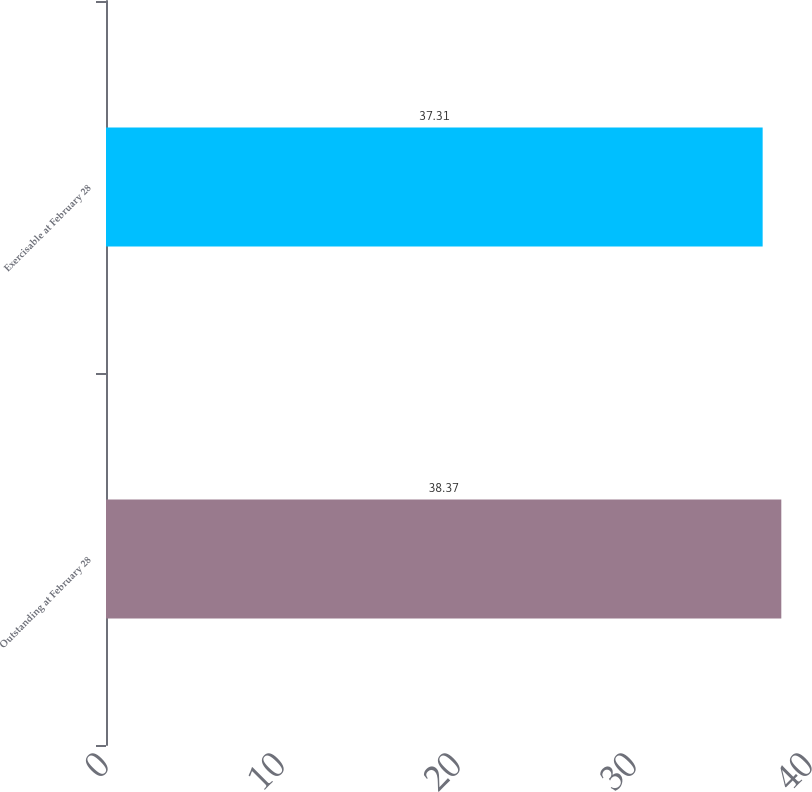<chart> <loc_0><loc_0><loc_500><loc_500><bar_chart><fcel>Outstanding at February 28<fcel>Exercisable at February 28<nl><fcel>38.37<fcel>37.31<nl></chart> 